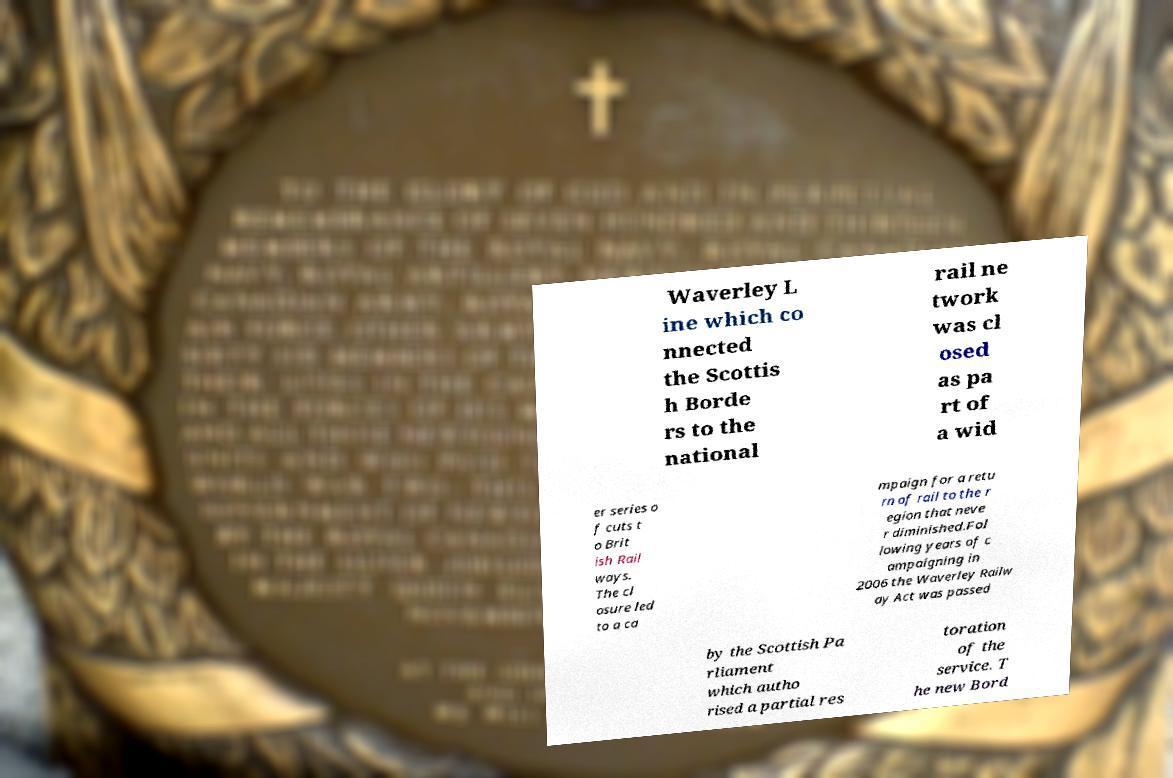Please identify and transcribe the text found in this image. Waverley L ine which co nnected the Scottis h Borde rs to the national rail ne twork was cl osed as pa rt of a wid er series o f cuts t o Brit ish Rail ways. The cl osure led to a ca mpaign for a retu rn of rail to the r egion that neve r diminished.Fol lowing years of c ampaigning in 2006 the Waverley Railw ay Act was passed by the Scottish Pa rliament which autho rised a partial res toration of the service. T he new Bord 